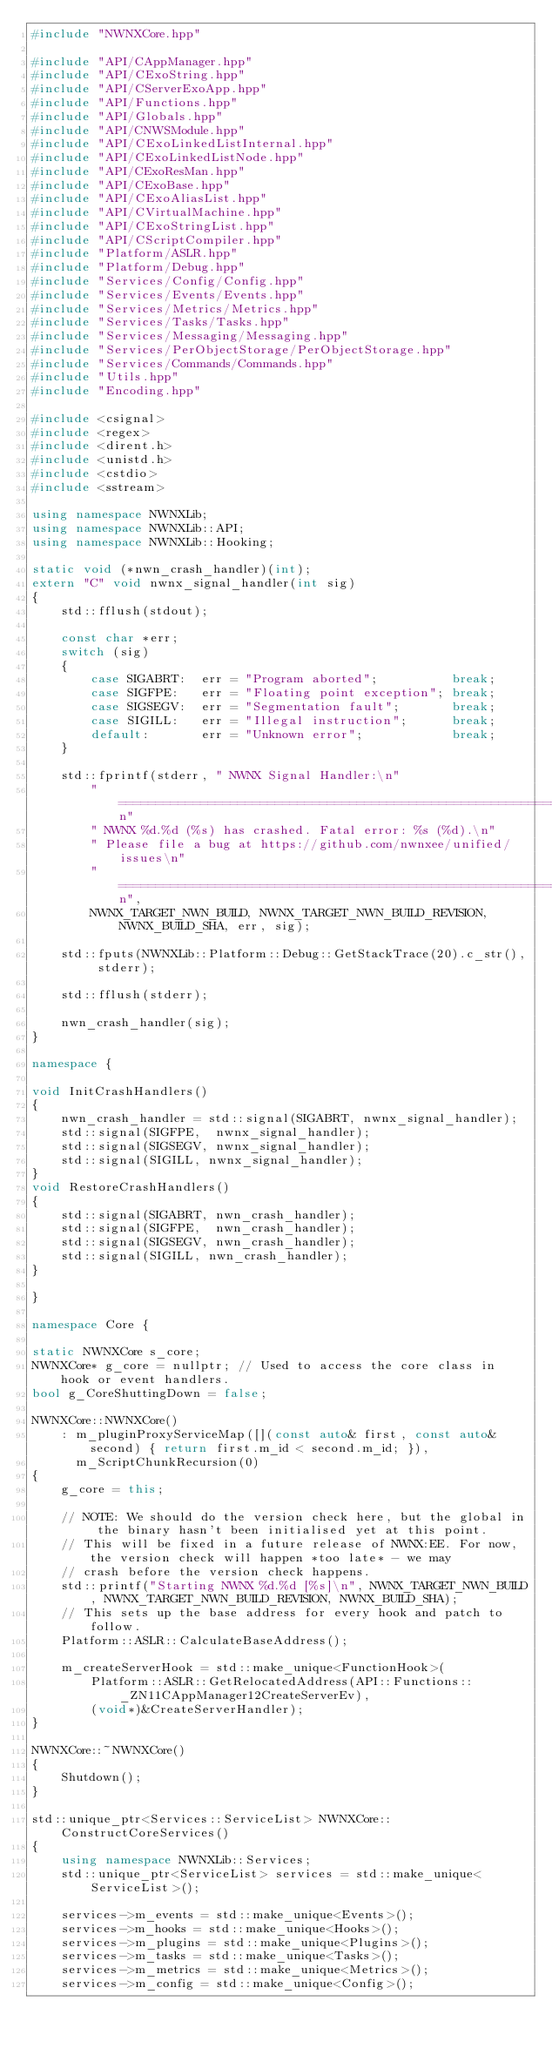<code> <loc_0><loc_0><loc_500><loc_500><_C++_>#include "NWNXCore.hpp"

#include "API/CAppManager.hpp"
#include "API/CExoString.hpp"
#include "API/CServerExoApp.hpp"
#include "API/Functions.hpp"
#include "API/Globals.hpp"
#include "API/CNWSModule.hpp"
#include "API/CExoLinkedListInternal.hpp"
#include "API/CExoLinkedListNode.hpp"
#include "API/CExoResMan.hpp"
#include "API/CExoBase.hpp"
#include "API/CExoAliasList.hpp"
#include "API/CVirtualMachine.hpp"
#include "API/CExoStringList.hpp"
#include "API/CScriptCompiler.hpp"
#include "Platform/ASLR.hpp"
#include "Platform/Debug.hpp"
#include "Services/Config/Config.hpp"
#include "Services/Events/Events.hpp"
#include "Services/Metrics/Metrics.hpp"
#include "Services/Tasks/Tasks.hpp"
#include "Services/Messaging/Messaging.hpp"
#include "Services/PerObjectStorage/PerObjectStorage.hpp"
#include "Services/Commands/Commands.hpp"
#include "Utils.hpp"
#include "Encoding.hpp"

#include <csignal>
#include <regex>
#include <dirent.h>
#include <unistd.h>
#include <cstdio>
#include <sstream>

using namespace NWNXLib;
using namespace NWNXLib::API;
using namespace NWNXLib::Hooking;

static void (*nwn_crash_handler)(int);
extern "C" void nwnx_signal_handler(int sig)
{
    std::fflush(stdout);

    const char *err;
    switch (sig)
    {
        case SIGABRT:  err = "Program aborted";          break;
        case SIGFPE:   err = "Floating point exception"; break;
        case SIGSEGV:  err = "Segmentation fault";       break;
        case SIGILL:   err = "Illegal instruction";      break;
        default:       err = "Unknown error";            break;
    }

    std::fprintf(stderr, " NWNX Signal Handler:\n"
        "==============================================================\n"
        " NWNX %d.%d (%s) has crashed. Fatal error: %s (%d).\n"
        " Please file a bug at https://github.com/nwnxee/unified/issues\n"
        "==============================================================\n",
        NWNX_TARGET_NWN_BUILD, NWNX_TARGET_NWN_BUILD_REVISION, NWNX_BUILD_SHA, err, sig);

    std::fputs(NWNXLib::Platform::Debug::GetStackTrace(20).c_str(), stderr);

    std::fflush(stderr);

    nwn_crash_handler(sig);
}

namespace {

void InitCrashHandlers()
{
    nwn_crash_handler = std::signal(SIGABRT, nwnx_signal_handler);
    std::signal(SIGFPE,  nwnx_signal_handler);
    std::signal(SIGSEGV, nwnx_signal_handler);
    std::signal(SIGILL, nwnx_signal_handler);
}
void RestoreCrashHandlers()
{
    std::signal(SIGABRT, nwn_crash_handler);
    std::signal(SIGFPE,  nwn_crash_handler);
    std::signal(SIGSEGV, nwn_crash_handler);
    std::signal(SIGILL, nwn_crash_handler);
}

}

namespace Core {

static NWNXCore s_core;
NWNXCore* g_core = nullptr; // Used to access the core class in hook or event handlers.
bool g_CoreShuttingDown = false;

NWNXCore::NWNXCore()
    : m_pluginProxyServiceMap([](const auto& first, const auto& second) { return first.m_id < second.m_id; }),
      m_ScriptChunkRecursion(0)
{
    g_core = this;

    // NOTE: We should do the version check here, but the global in the binary hasn't been initialised yet at this point.
    // This will be fixed in a future release of NWNX:EE. For now, the version check will happen *too late* - we may
    // crash before the version check happens.
    std::printf("Starting NWNX %d.%d [%s]\n", NWNX_TARGET_NWN_BUILD, NWNX_TARGET_NWN_BUILD_REVISION, NWNX_BUILD_SHA);
    // This sets up the base address for every hook and patch to follow.
    Platform::ASLR::CalculateBaseAddress();

    m_createServerHook = std::make_unique<FunctionHook>(
        Platform::ASLR::GetRelocatedAddress(API::Functions::_ZN11CAppManager12CreateServerEv),
        (void*)&CreateServerHandler);
}

NWNXCore::~NWNXCore()
{
    Shutdown();
}

std::unique_ptr<Services::ServiceList> NWNXCore::ConstructCoreServices()
{
    using namespace NWNXLib::Services;
    std::unique_ptr<ServiceList> services = std::make_unique<ServiceList>();

    services->m_events = std::make_unique<Events>();
    services->m_hooks = std::make_unique<Hooks>();
    services->m_plugins = std::make_unique<Plugins>();
    services->m_tasks = std::make_unique<Tasks>();
    services->m_metrics = std::make_unique<Metrics>();
    services->m_config = std::make_unique<Config>();</code> 